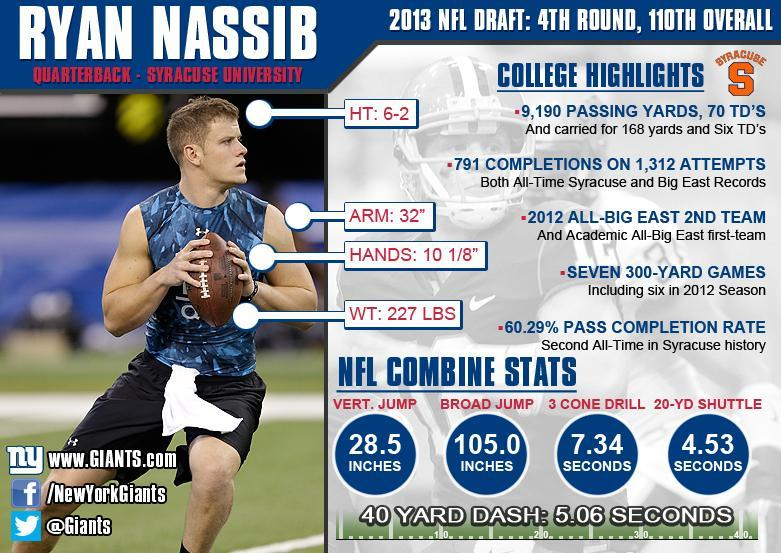What is the 3 cone drill score in the NFL combine stats?
Answer the question with a short phrase. 7.34 seconds How much is the 20-yd shuttle measurement? 4.53 seconds What is the vertical jump score in NFL combine stats? 28.5 What is the player's height? 6-2 What is the weight of the player as per the infographic? 227 lbs How much is the broad jump measurement for Ryan Nassib? 105.0 What is the team's twitter handle mentioned in the infographic? @Giants 